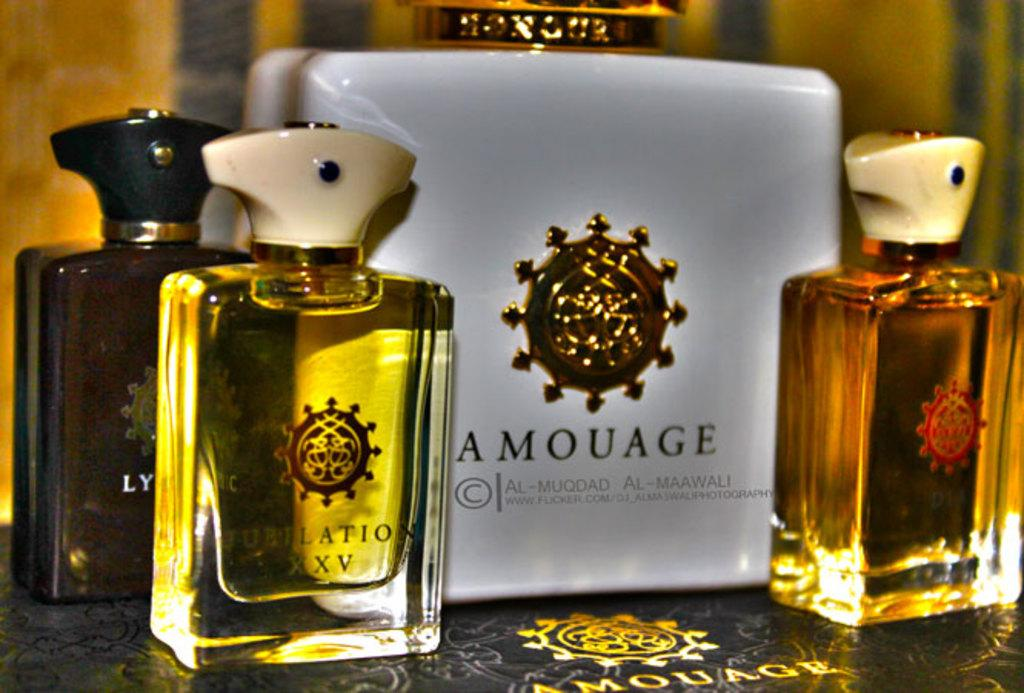<image>
Relay a brief, clear account of the picture shown. the word maawali is on the gray item 